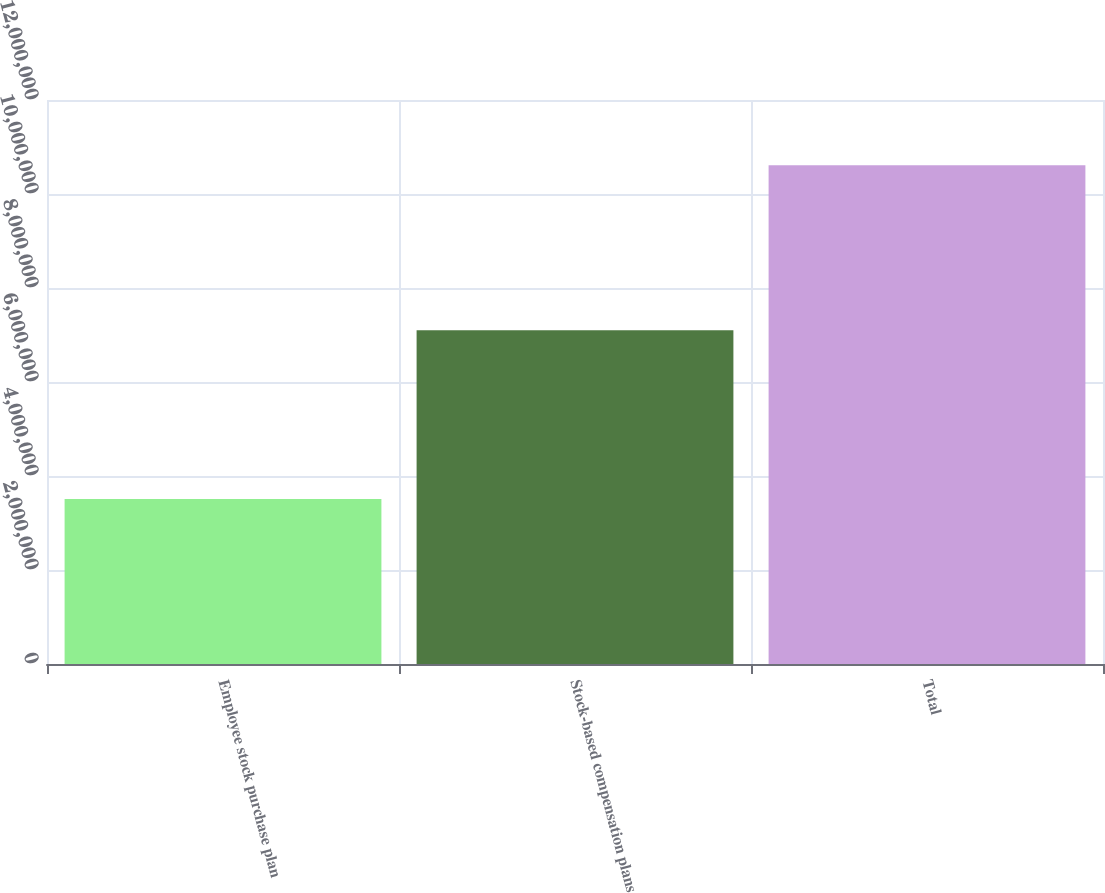Convert chart to OTSL. <chart><loc_0><loc_0><loc_500><loc_500><bar_chart><fcel>Employee stock purchase plan<fcel>Stock-based compensation plans<fcel>Total<nl><fcel>3.50901e+06<fcel>7.10011e+06<fcel>1.06091e+07<nl></chart> 